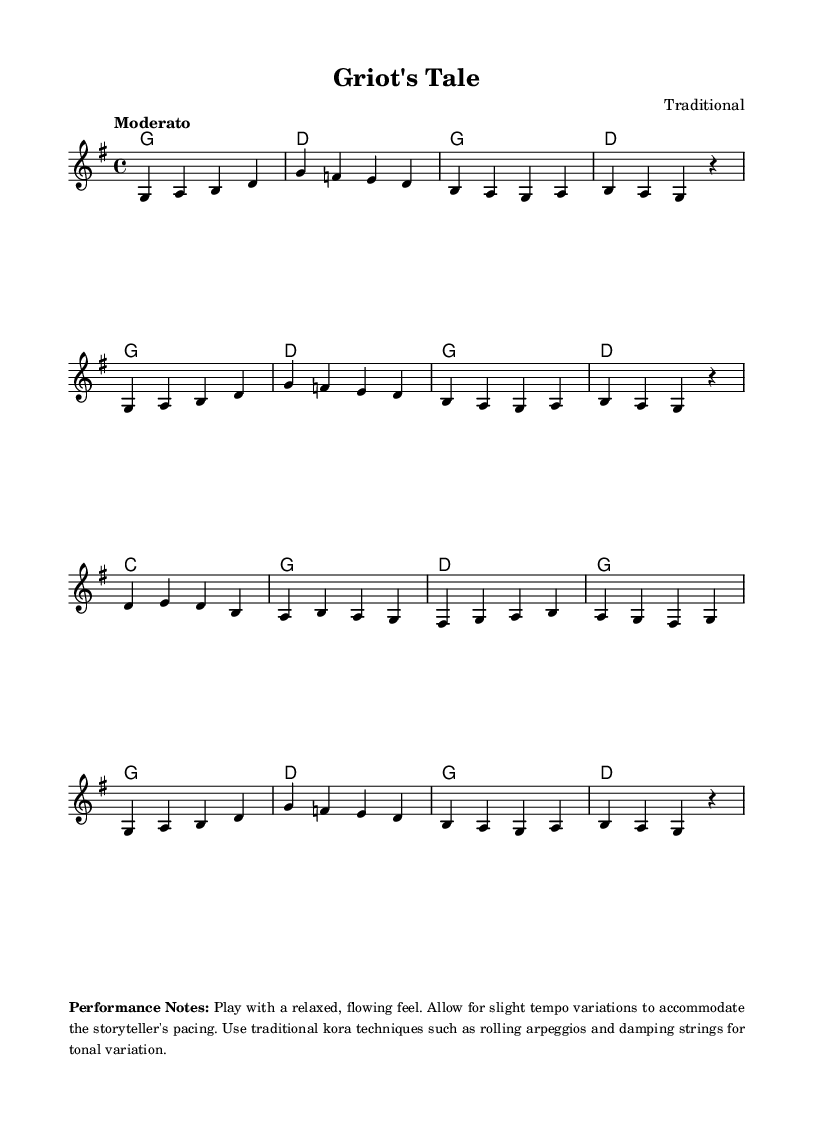What is the key signature of this music? The key signature is G major, which has one sharp (F#). This can be determined by looking at the signature markings at the beginning of the staff.
Answer: G major What is the time signature of this piece? The time signature is 4/4, which indicates four beats in each measure and a quarter note gets one beat. This can be found at the beginning of the score next to the key signature.
Answer: 4/4 What is the tempo marking for this piece? The tempo marking is "Moderato," which indicates a moderate speed of the music. It is found at the start of the piece after the time signature.
Answer: Moderato How many measures are in the kora melody section? There are 8 measures in the kora melody section. By counting the vertical lines that indicate measure boundaries in the kora part, we find eight distinct sections.
Answer: 8 Which traditional instrument is featured in this piece? The traditional instrument featured is the kora, as indicated in the title of the scoring related to the voice. The notation is specifically written for kora in the score.
Answer: Kora What performance technique is suggested in the notes? The suggested performance technique is "rolling arpeggios." This is specified in the performance notes to enhance the storytelling aspect of the music.
Answer: Rolling arpeggios What provides the tonal variation in the kora performance? The tonal variation in the kora performance comes from "damping strings," which is mentioned in the performance notes as a technique to be used.
Answer: Damping strings 